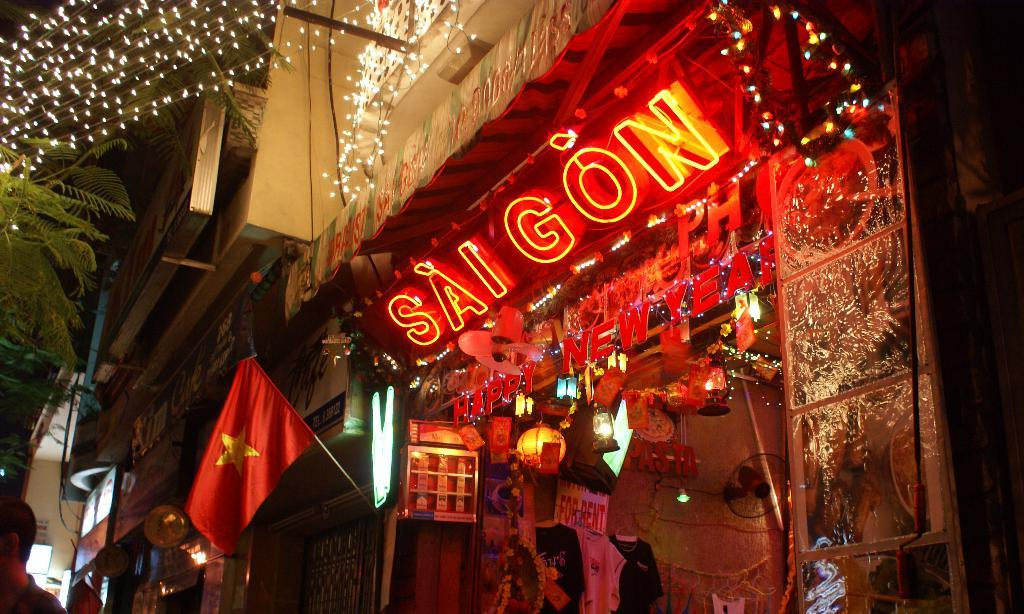What can be seen in the image related to storytelling? There are stories in the image. What type of advertising signs are present in the image? There are hoardings in the image. What color is the flag in the image? There is a red flag in the image. What type of illumination is visible in the image? There are lights in the image. What type of vegetation is present in the image? There are green leaves in the image. Where is the person located in the image? There is a person on the left side of the image. What type of system is being used by the person to cut the stomach in the image? There is no person cutting a stomach in the image; it does not depict any such activity. What type of knife is being used by the person to cut the stomach in the image? There is no person cutting a stomach in the image, so there is no knife present for that purpose. 